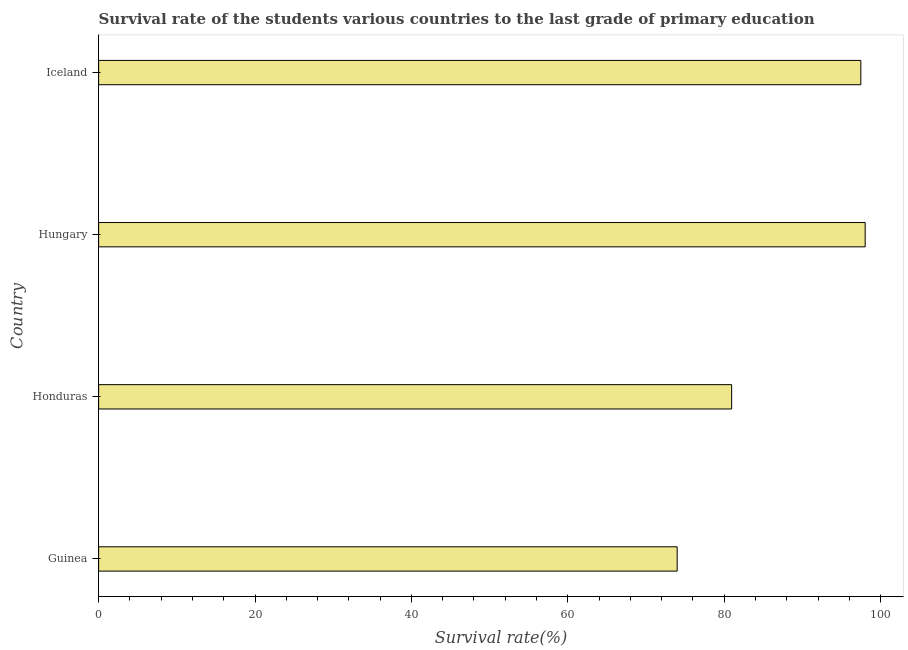Does the graph contain any zero values?
Ensure brevity in your answer.  No. Does the graph contain grids?
Keep it short and to the point. No. What is the title of the graph?
Make the answer very short. Survival rate of the students various countries to the last grade of primary education. What is the label or title of the X-axis?
Make the answer very short. Survival rate(%). What is the label or title of the Y-axis?
Your answer should be compact. Country. What is the survival rate in primary education in Iceland?
Offer a terse response. 97.48. Across all countries, what is the maximum survival rate in primary education?
Your response must be concise. 98.03. Across all countries, what is the minimum survival rate in primary education?
Your answer should be compact. 73.99. In which country was the survival rate in primary education maximum?
Your answer should be compact. Hungary. In which country was the survival rate in primary education minimum?
Provide a short and direct response. Guinea. What is the sum of the survival rate in primary education?
Ensure brevity in your answer.  350.45. What is the difference between the survival rate in primary education in Guinea and Honduras?
Ensure brevity in your answer.  -6.97. What is the average survival rate in primary education per country?
Offer a terse response. 87.61. What is the median survival rate in primary education?
Ensure brevity in your answer.  89.22. In how many countries, is the survival rate in primary education greater than 20 %?
Keep it short and to the point. 4. What is the ratio of the survival rate in primary education in Honduras to that in Iceland?
Give a very brief answer. 0.83. Is the survival rate in primary education in Honduras less than that in Hungary?
Offer a terse response. Yes. What is the difference between the highest and the second highest survival rate in primary education?
Make the answer very short. 0.55. Is the sum of the survival rate in primary education in Honduras and Hungary greater than the maximum survival rate in primary education across all countries?
Give a very brief answer. Yes. What is the difference between the highest and the lowest survival rate in primary education?
Your answer should be very brief. 24.04. How many bars are there?
Keep it short and to the point. 4. What is the difference between two consecutive major ticks on the X-axis?
Keep it short and to the point. 20. What is the Survival rate(%) of Guinea?
Your answer should be compact. 73.99. What is the Survival rate(%) in Honduras?
Offer a terse response. 80.96. What is the Survival rate(%) of Hungary?
Your answer should be very brief. 98.03. What is the Survival rate(%) of Iceland?
Provide a succinct answer. 97.48. What is the difference between the Survival rate(%) in Guinea and Honduras?
Your answer should be very brief. -6.97. What is the difference between the Survival rate(%) in Guinea and Hungary?
Offer a very short reply. -24.04. What is the difference between the Survival rate(%) in Guinea and Iceland?
Keep it short and to the point. -23.49. What is the difference between the Survival rate(%) in Honduras and Hungary?
Your answer should be compact. -17.08. What is the difference between the Survival rate(%) in Honduras and Iceland?
Make the answer very short. -16.52. What is the difference between the Survival rate(%) in Hungary and Iceland?
Ensure brevity in your answer.  0.55. What is the ratio of the Survival rate(%) in Guinea to that in Honduras?
Your answer should be compact. 0.91. What is the ratio of the Survival rate(%) in Guinea to that in Hungary?
Provide a short and direct response. 0.76. What is the ratio of the Survival rate(%) in Guinea to that in Iceland?
Your answer should be compact. 0.76. What is the ratio of the Survival rate(%) in Honduras to that in Hungary?
Offer a very short reply. 0.83. What is the ratio of the Survival rate(%) in Honduras to that in Iceland?
Make the answer very short. 0.83. 